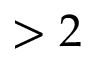Convert formula to latex. <formula><loc_0><loc_0><loc_500><loc_500>> 2</formula> 